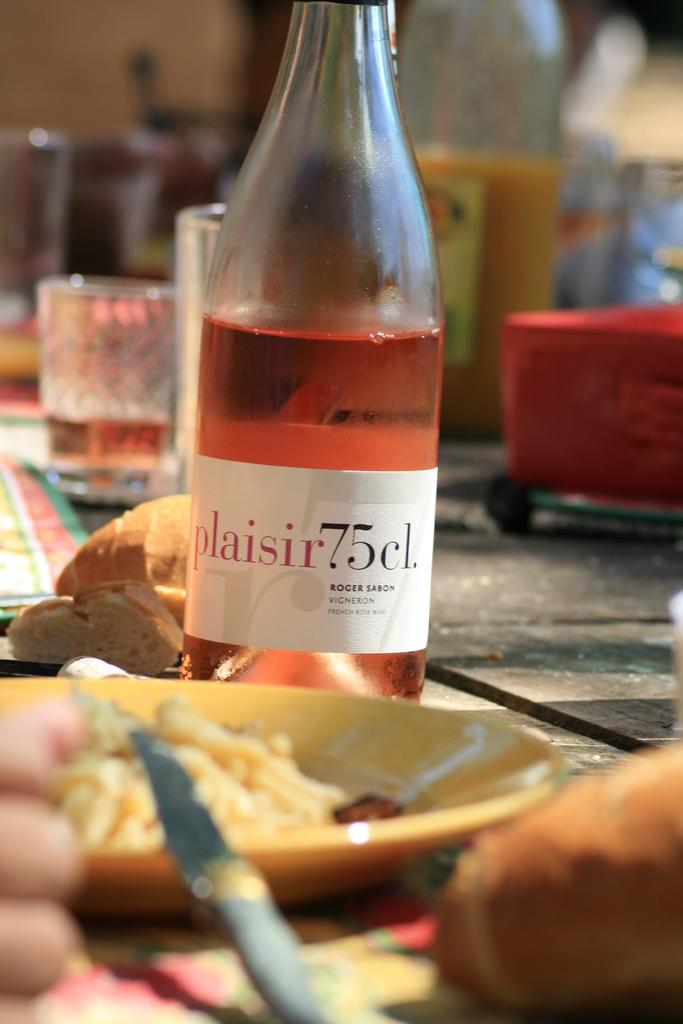<image>
Share a concise interpretation of the image provided. A half empty bottle of Roger Sabon Vigneron wine on a table. 